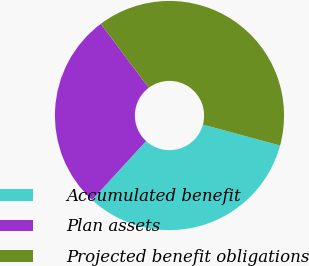<chart> <loc_0><loc_0><loc_500><loc_500><pie_chart><fcel>Accumulated benefit<fcel>Plan assets<fcel>Projected benefit obligations<nl><fcel>32.6%<fcel>27.96%<fcel>39.44%<nl></chart> 